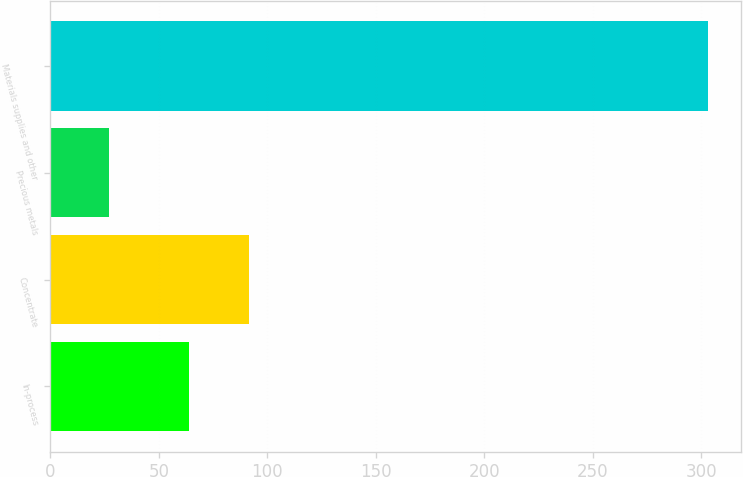<chart> <loc_0><loc_0><loc_500><loc_500><bar_chart><fcel>In-process<fcel>Concentrate<fcel>Precious metals<fcel>Materials supplies and other<nl><fcel>64<fcel>91.6<fcel>27<fcel>303<nl></chart> 